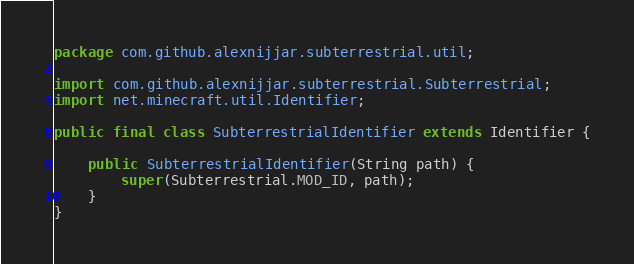Convert code to text. <code><loc_0><loc_0><loc_500><loc_500><_Java_>package com.github.alexnijjar.subterrestrial.util;

import com.github.alexnijjar.subterrestrial.Subterrestrial;
import net.minecraft.util.Identifier;

public final class SubterrestrialIdentifier extends Identifier {

    public SubterrestrialIdentifier(String path) {
        super(Subterrestrial.MOD_ID, path);
    }
}
</code> 